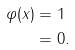Convert formula to latex. <formula><loc_0><loc_0><loc_500><loc_500>\varphi ( x ) & = 1 \\ & = 0 .</formula> 